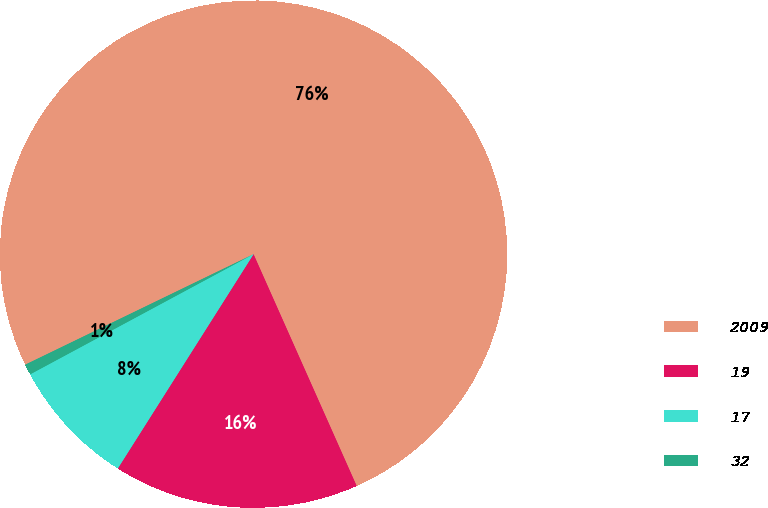Convert chart. <chart><loc_0><loc_0><loc_500><loc_500><pie_chart><fcel>2009<fcel>19<fcel>17<fcel>32<nl><fcel>75.52%<fcel>15.65%<fcel>8.16%<fcel>0.68%<nl></chart> 